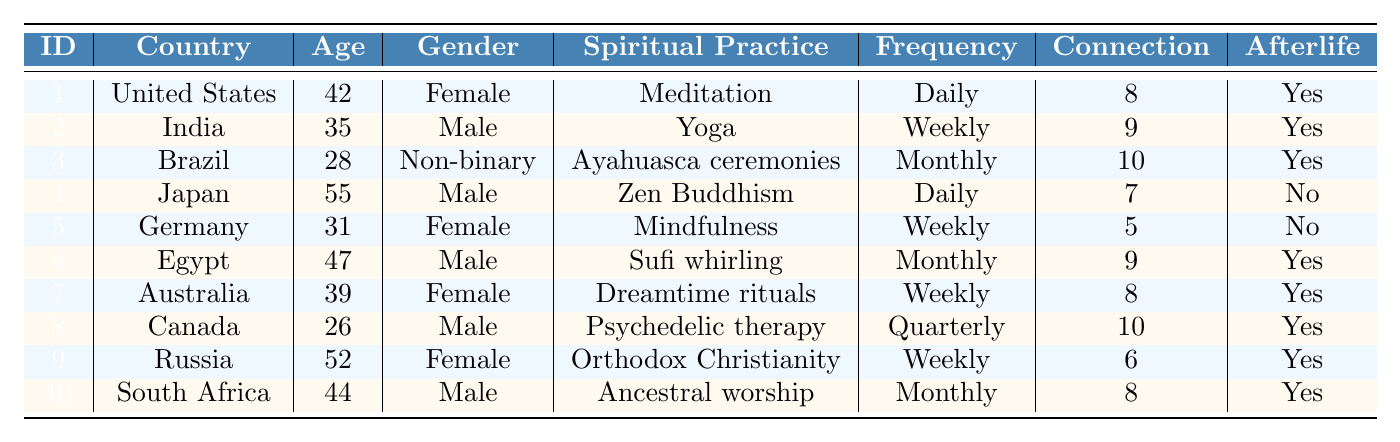What is the spiritual practice of the respondent from Brazil? By looking at the row of the respondent from Brazil, we can see that their spiritual practice is "Ayahuasca ceremonies."
Answer: Ayahuasca ceremonies How many respondents reported a transcendent experience? We can count the "reported_transcendent_experience" column for those marked as true. There are 7 respondents who reported a transcendent experience.
Answer: 7 What is the average connection to higher consciousness for all respondents? To find the average, sum the values of the "connection_to_higher_consciousness" column (8 + 9 + 10 + 7 + 5 + 9 + 8 + 10 + 6 + 8 = 80) and divide by the number of respondents (80/10 = 8).
Answer: 8 Which country has the highest reported connection to higher consciousness? Looking through the "connection_to_higher_consciousness" column, Brazil has the highest value of 10.
Answer: Brazil Do any male respondents practice mindfulness? In the table, we can see that Germany's respondent, who is male, practices mindfulness but does not report a transcendent experience.
Answer: No What percentage of respondents believe in an afterlife? There are 8 respondents who believe in an afterlife out of 10 total respondents. Thus, the percentage is (8/10) * 100 = 80%.
Answer: 80% What is the most common frequency of spiritual practice among respondents? The frequencies are Daily (3), Weekly (4), Monthly (3), and Quarterly (1). Weekly is the most common frequency with 4 respondents.
Answer: Weekly What is the difference in age between the youngest and oldest respondents? The youngest respondent is 26 years old from Canada and the oldest is 55 years old from Japan. The difference is 55 - 26 = 29 years.
Answer: 29 Which spiritual practice has the highest impact on daily life? Reviewing the "impact_on_daily_life" column, the highest value is 9, associated with both Brazil and Canada’s respondents.
Answer: Ayahuasca ceremonies and Psychedelic therapy How many respondents practice daily spiritual practices and report a transcendent experience? The respondents practicing daily are from the United States and Japan. Only the United States respondent reported a transcendent experience.
Answer: 1 